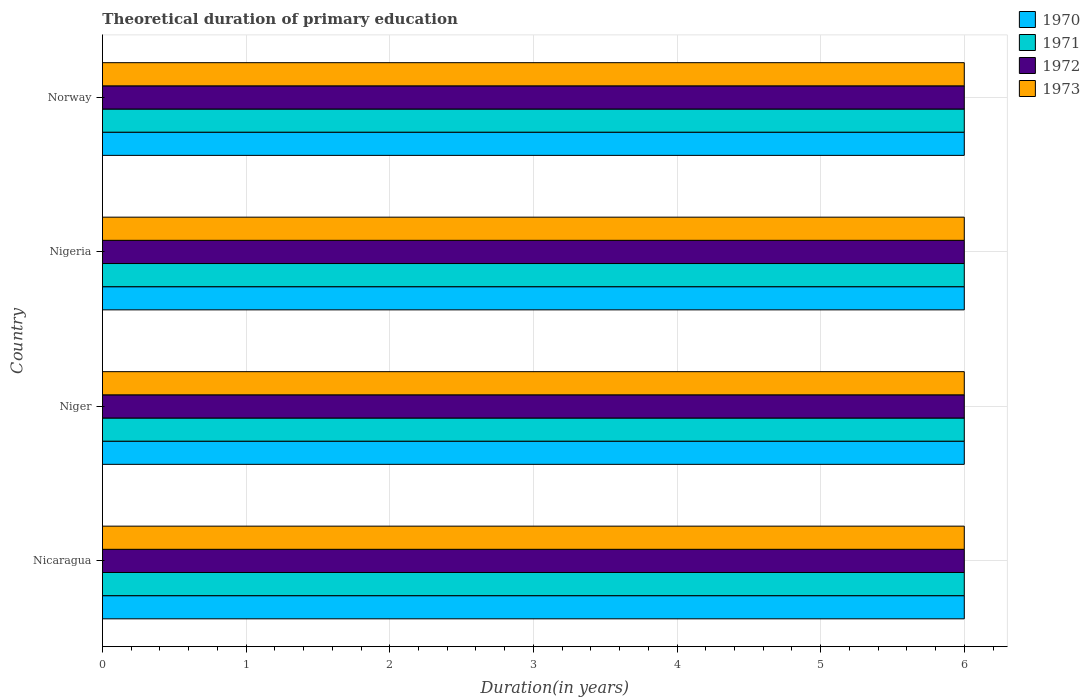Are the number of bars per tick equal to the number of legend labels?
Offer a terse response. Yes. What is the label of the 2nd group of bars from the top?
Your answer should be compact. Nigeria. In how many cases, is the number of bars for a given country not equal to the number of legend labels?
Your answer should be very brief. 0. What is the total theoretical duration of primary education in 1972 in Nigeria?
Ensure brevity in your answer.  6. Across all countries, what is the minimum total theoretical duration of primary education in 1970?
Offer a terse response. 6. In which country was the total theoretical duration of primary education in 1972 maximum?
Your answer should be compact. Nicaragua. In which country was the total theoretical duration of primary education in 1973 minimum?
Your response must be concise. Nicaragua. What is the difference between the total theoretical duration of primary education in 1970 in Nigeria and the total theoretical duration of primary education in 1971 in Norway?
Keep it short and to the point. 0. What is the difference between the total theoretical duration of primary education in 1970 and total theoretical duration of primary education in 1972 in Norway?
Provide a short and direct response. 0. In how many countries, is the total theoretical duration of primary education in 1971 greater than 4.2 years?
Ensure brevity in your answer.  4. What is the ratio of the total theoretical duration of primary education in 1973 in Nigeria to that in Norway?
Your response must be concise. 1. Is the total theoretical duration of primary education in 1970 in Niger less than that in Norway?
Offer a very short reply. No. Is the difference between the total theoretical duration of primary education in 1970 in Nigeria and Norway greater than the difference between the total theoretical duration of primary education in 1972 in Nigeria and Norway?
Give a very brief answer. No. What is the difference between the highest and the second highest total theoretical duration of primary education in 1970?
Your response must be concise. 0. What is the difference between the highest and the lowest total theoretical duration of primary education in 1972?
Give a very brief answer. 0. In how many countries, is the total theoretical duration of primary education in 1970 greater than the average total theoretical duration of primary education in 1970 taken over all countries?
Your answer should be compact. 0. Is the sum of the total theoretical duration of primary education in 1973 in Nicaragua and Norway greater than the maximum total theoretical duration of primary education in 1971 across all countries?
Give a very brief answer. Yes. What does the 3rd bar from the bottom in Nigeria represents?
Keep it short and to the point. 1972. How many bars are there?
Offer a very short reply. 16. Are all the bars in the graph horizontal?
Your response must be concise. Yes. How many countries are there in the graph?
Give a very brief answer. 4. What is the difference between two consecutive major ticks on the X-axis?
Ensure brevity in your answer.  1. What is the title of the graph?
Make the answer very short. Theoretical duration of primary education. What is the label or title of the X-axis?
Your answer should be compact. Duration(in years). What is the label or title of the Y-axis?
Give a very brief answer. Country. What is the Duration(in years) of 1970 in Nicaragua?
Keep it short and to the point. 6. What is the Duration(in years) in 1972 in Nicaragua?
Offer a very short reply. 6. What is the Duration(in years) of 1973 in Nicaragua?
Your answer should be compact. 6. What is the Duration(in years) in 1970 in Niger?
Make the answer very short. 6. What is the Duration(in years) in 1971 in Niger?
Ensure brevity in your answer.  6. What is the Duration(in years) of 1973 in Niger?
Keep it short and to the point. 6. What is the Duration(in years) in 1972 in Norway?
Ensure brevity in your answer.  6. What is the Duration(in years) in 1973 in Norway?
Give a very brief answer. 6. Across all countries, what is the maximum Duration(in years) of 1970?
Your answer should be very brief. 6. Across all countries, what is the maximum Duration(in years) of 1972?
Provide a short and direct response. 6. Across all countries, what is the maximum Duration(in years) in 1973?
Make the answer very short. 6. Across all countries, what is the minimum Duration(in years) in 1971?
Provide a succinct answer. 6. Across all countries, what is the minimum Duration(in years) in 1973?
Make the answer very short. 6. What is the total Duration(in years) in 1970 in the graph?
Your answer should be compact. 24. What is the total Duration(in years) in 1971 in the graph?
Give a very brief answer. 24. What is the difference between the Duration(in years) in 1971 in Nicaragua and that in Niger?
Offer a very short reply. 0. What is the difference between the Duration(in years) in 1972 in Nicaragua and that in Niger?
Provide a succinct answer. 0. What is the difference between the Duration(in years) of 1973 in Nicaragua and that in Niger?
Your answer should be very brief. 0. What is the difference between the Duration(in years) in 1970 in Nicaragua and that in Nigeria?
Offer a very short reply. 0. What is the difference between the Duration(in years) in 1972 in Nicaragua and that in Nigeria?
Provide a succinct answer. 0. What is the difference between the Duration(in years) of 1970 in Nicaragua and that in Norway?
Provide a short and direct response. 0. What is the difference between the Duration(in years) of 1972 in Nicaragua and that in Norway?
Provide a succinct answer. 0. What is the difference between the Duration(in years) in 1973 in Nicaragua and that in Norway?
Give a very brief answer. 0. What is the difference between the Duration(in years) of 1970 in Niger and that in Nigeria?
Ensure brevity in your answer.  0. What is the difference between the Duration(in years) in 1970 in Niger and that in Norway?
Give a very brief answer. 0. What is the difference between the Duration(in years) of 1972 in Niger and that in Norway?
Your answer should be very brief. 0. What is the difference between the Duration(in years) in 1973 in Niger and that in Norway?
Offer a terse response. 0. What is the difference between the Duration(in years) of 1970 in Nigeria and that in Norway?
Make the answer very short. 0. What is the difference between the Duration(in years) in 1973 in Nigeria and that in Norway?
Ensure brevity in your answer.  0. What is the difference between the Duration(in years) of 1970 in Nicaragua and the Duration(in years) of 1971 in Niger?
Offer a terse response. 0. What is the difference between the Duration(in years) in 1970 in Nicaragua and the Duration(in years) in 1972 in Niger?
Offer a very short reply. 0. What is the difference between the Duration(in years) in 1970 in Nicaragua and the Duration(in years) in 1973 in Niger?
Your answer should be compact. 0. What is the difference between the Duration(in years) in 1972 in Nicaragua and the Duration(in years) in 1973 in Niger?
Your answer should be compact. 0. What is the difference between the Duration(in years) in 1970 in Nicaragua and the Duration(in years) in 1972 in Nigeria?
Offer a very short reply. 0. What is the difference between the Duration(in years) in 1970 in Nicaragua and the Duration(in years) in 1973 in Nigeria?
Offer a terse response. 0. What is the difference between the Duration(in years) of 1971 in Nicaragua and the Duration(in years) of 1972 in Nigeria?
Make the answer very short. 0. What is the difference between the Duration(in years) of 1970 in Nicaragua and the Duration(in years) of 1972 in Norway?
Give a very brief answer. 0. What is the difference between the Duration(in years) in 1971 in Nicaragua and the Duration(in years) in 1972 in Norway?
Keep it short and to the point. 0. What is the difference between the Duration(in years) in 1971 in Nicaragua and the Duration(in years) in 1973 in Norway?
Make the answer very short. 0. What is the difference between the Duration(in years) of 1971 in Niger and the Duration(in years) of 1972 in Nigeria?
Give a very brief answer. 0. What is the difference between the Duration(in years) of 1972 in Niger and the Duration(in years) of 1973 in Nigeria?
Make the answer very short. 0. What is the difference between the Duration(in years) in 1970 in Niger and the Duration(in years) in 1971 in Norway?
Provide a short and direct response. 0. What is the difference between the Duration(in years) of 1970 in Niger and the Duration(in years) of 1972 in Norway?
Give a very brief answer. 0. What is the difference between the Duration(in years) in 1970 in Niger and the Duration(in years) in 1973 in Norway?
Keep it short and to the point. 0. What is the difference between the Duration(in years) of 1971 in Niger and the Duration(in years) of 1972 in Norway?
Keep it short and to the point. 0. What is the difference between the Duration(in years) in 1972 in Niger and the Duration(in years) in 1973 in Norway?
Provide a succinct answer. 0. What is the difference between the Duration(in years) of 1970 in Nigeria and the Duration(in years) of 1971 in Norway?
Make the answer very short. 0. What is the difference between the Duration(in years) of 1971 in Nigeria and the Duration(in years) of 1972 in Norway?
Provide a succinct answer. 0. What is the average Duration(in years) of 1970 per country?
Provide a succinct answer. 6. What is the difference between the Duration(in years) of 1970 and Duration(in years) of 1972 in Nicaragua?
Your response must be concise. 0. What is the difference between the Duration(in years) of 1971 and Duration(in years) of 1973 in Nicaragua?
Give a very brief answer. 0. What is the difference between the Duration(in years) of 1970 and Duration(in years) of 1971 in Niger?
Make the answer very short. 0. What is the difference between the Duration(in years) in 1972 and Duration(in years) in 1973 in Niger?
Provide a short and direct response. 0. What is the difference between the Duration(in years) in 1970 and Duration(in years) in 1971 in Nigeria?
Keep it short and to the point. 0. What is the difference between the Duration(in years) of 1970 and Duration(in years) of 1972 in Nigeria?
Your answer should be very brief. 0. What is the difference between the Duration(in years) in 1970 and Duration(in years) in 1973 in Nigeria?
Your answer should be compact. 0. What is the difference between the Duration(in years) in 1971 and Duration(in years) in 1973 in Nigeria?
Give a very brief answer. 0. What is the difference between the Duration(in years) of 1970 and Duration(in years) of 1972 in Norway?
Your answer should be compact. 0. What is the difference between the Duration(in years) of 1971 and Duration(in years) of 1972 in Norway?
Your answer should be compact. 0. What is the difference between the Duration(in years) of 1972 and Duration(in years) of 1973 in Norway?
Give a very brief answer. 0. What is the ratio of the Duration(in years) in 1972 in Nicaragua to that in Niger?
Make the answer very short. 1. What is the ratio of the Duration(in years) of 1973 in Nicaragua to that in Niger?
Offer a very short reply. 1. What is the ratio of the Duration(in years) of 1970 in Nicaragua to that in Nigeria?
Offer a terse response. 1. What is the ratio of the Duration(in years) in 1972 in Nicaragua to that in Nigeria?
Provide a succinct answer. 1. What is the ratio of the Duration(in years) in 1973 in Nicaragua to that in Nigeria?
Provide a short and direct response. 1. What is the ratio of the Duration(in years) in 1970 in Nicaragua to that in Norway?
Offer a very short reply. 1. What is the ratio of the Duration(in years) in 1971 in Niger to that in Nigeria?
Provide a succinct answer. 1. What is the ratio of the Duration(in years) in 1972 in Niger to that in Nigeria?
Provide a succinct answer. 1. What is the ratio of the Duration(in years) of 1971 in Niger to that in Norway?
Offer a very short reply. 1. What is the ratio of the Duration(in years) of 1972 in Niger to that in Norway?
Keep it short and to the point. 1. What is the ratio of the Duration(in years) in 1973 in Niger to that in Norway?
Provide a succinct answer. 1. What is the ratio of the Duration(in years) in 1970 in Nigeria to that in Norway?
Make the answer very short. 1. What is the ratio of the Duration(in years) in 1972 in Nigeria to that in Norway?
Offer a terse response. 1. What is the ratio of the Duration(in years) in 1973 in Nigeria to that in Norway?
Your answer should be very brief. 1. What is the difference between the highest and the second highest Duration(in years) of 1971?
Keep it short and to the point. 0. What is the difference between the highest and the second highest Duration(in years) of 1973?
Give a very brief answer. 0. What is the difference between the highest and the lowest Duration(in years) of 1973?
Your response must be concise. 0. 